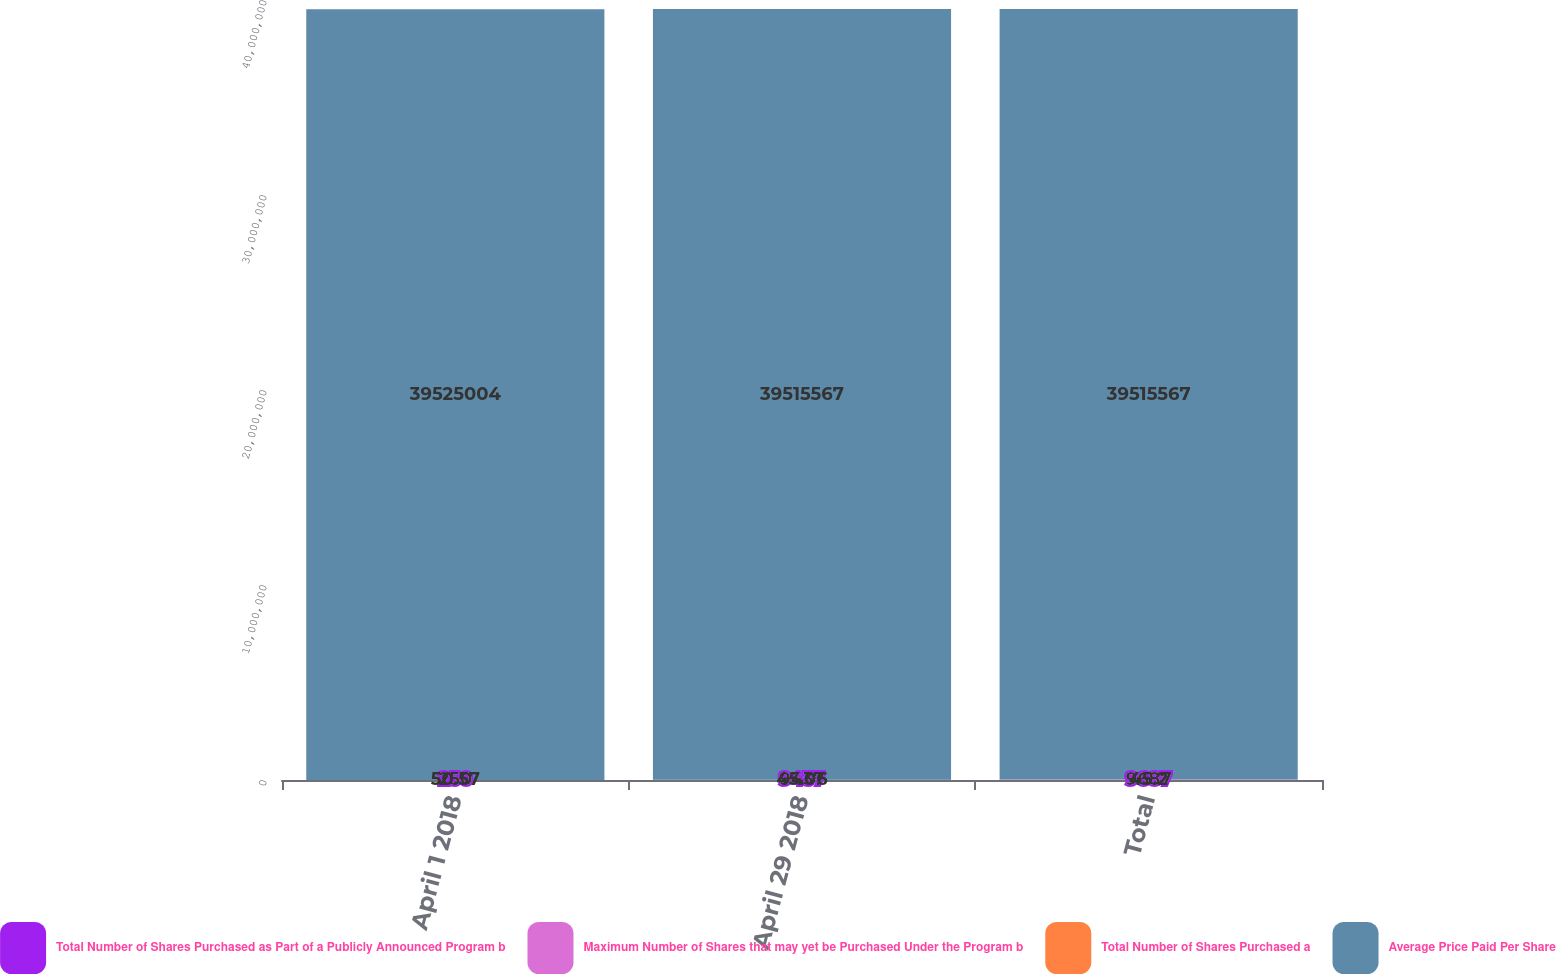Convert chart to OTSL. <chart><loc_0><loc_0><loc_500><loc_500><stacked_bar_chart><ecel><fcel>April 1 2018<fcel>April 29 2018<fcel>Total<nl><fcel>Total Number of Shares Purchased as Part of a Publicly Announced Program b<fcel>250<fcel>9437<fcel>9687<nl><fcel>Maximum Number of Shares that may yet be Purchased Under the Program b<fcel>50.57<fcel>45.06<fcel>45.2<nl><fcel>Total Number of Shares Purchased a<fcel>250<fcel>9437<fcel>9687<nl><fcel>Average Price Paid Per Share<fcel>3.9525e+07<fcel>3.95156e+07<fcel>3.95156e+07<nl></chart> 